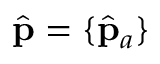<formula> <loc_0><loc_0><loc_500><loc_500>\hat { p } = \{ \hat { p } _ { a } \}</formula> 